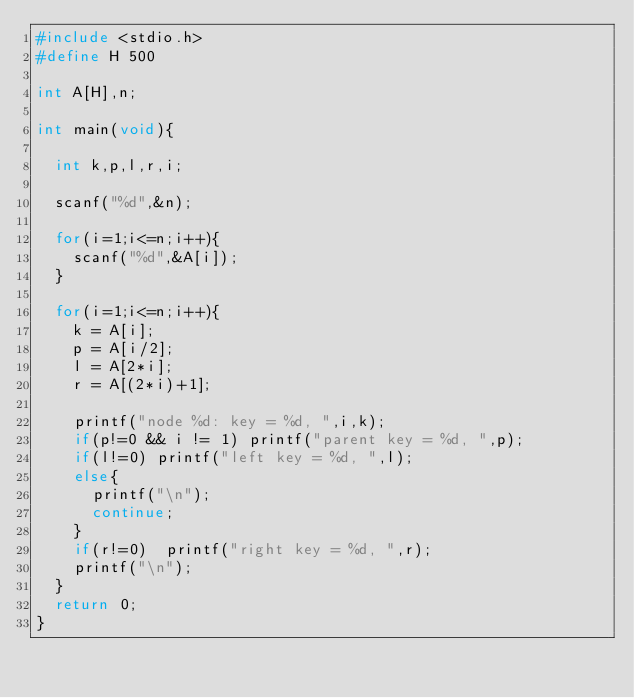<code> <loc_0><loc_0><loc_500><loc_500><_C_>#include <stdio.h>
#define H 500

int A[H],n;

int main(void){

  int k,p,l,r,i;

  scanf("%d",&n);

  for(i=1;i<=n;i++){
    scanf("%d",&A[i]);
  }

  for(i=1;i<=n;i++){
    k = A[i];
    p = A[i/2];
    l = A[2*i];
    r = A[(2*i)+1];

    printf("node %d: key = %d, ",i,k);
    if(p!=0 && i != 1) printf("parent key = %d, ",p);
    if(l!=0) printf("left key = %d, ",l);
    else{
      printf("\n");
      continue;
    }
    if(r!=0)  printf("right key = %d, ",r);
    printf("\n");
  }
  return 0;
}</code> 